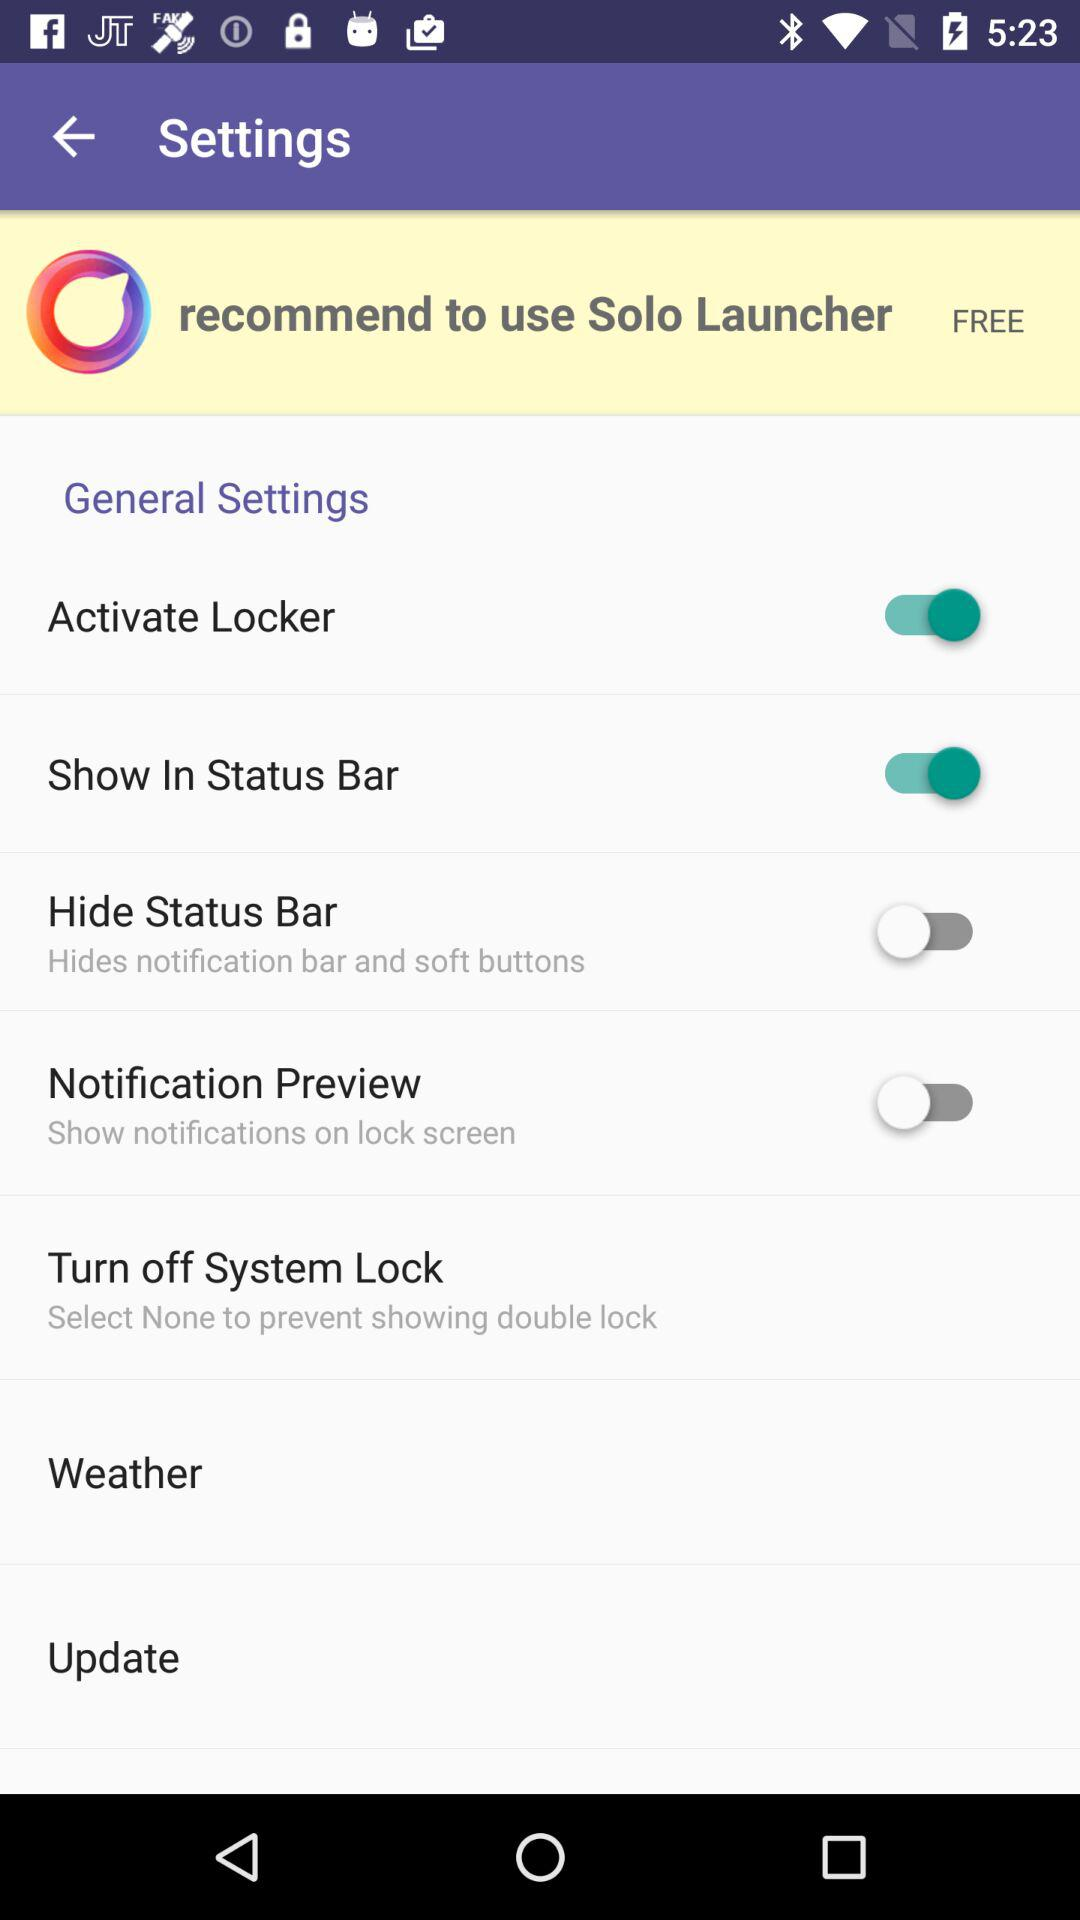What are the enabled options in the settings? The enabled options are "Activate Locker" and "Show In Status Bar". 